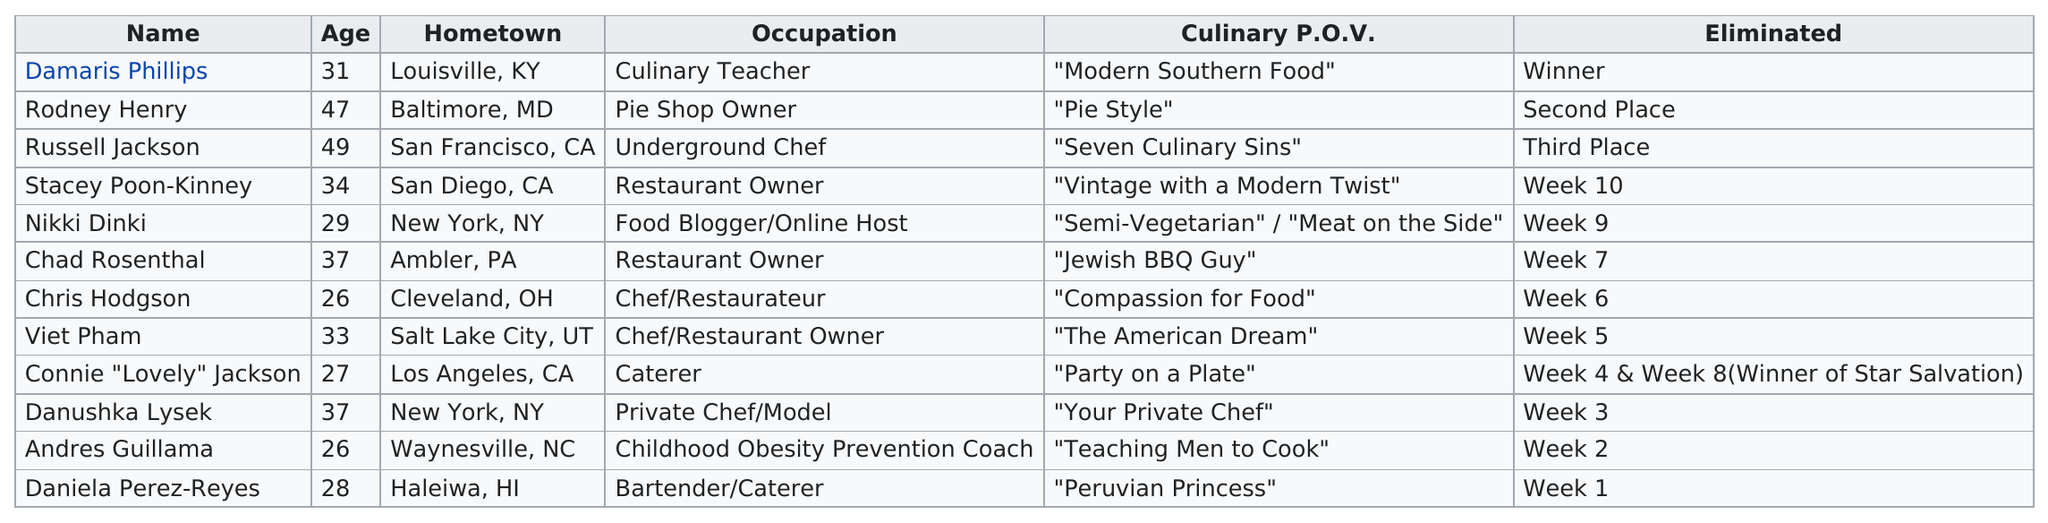Identify some key points in this picture. Daniela Perez-Reyes was the first contestant to be eliminated on the ninth season of Food Network Star. There were five competitors under the age of 30. Of the finalists listed, two are over the age of 40. Russel Jackson and one other finalist were from San Diego, California. Specifically, the other finalist was Stacey Poon-Kinney. Which contestant is the same age as Chris Hodgson? Andrés Guillama is the same age as Chris Hodgson. 